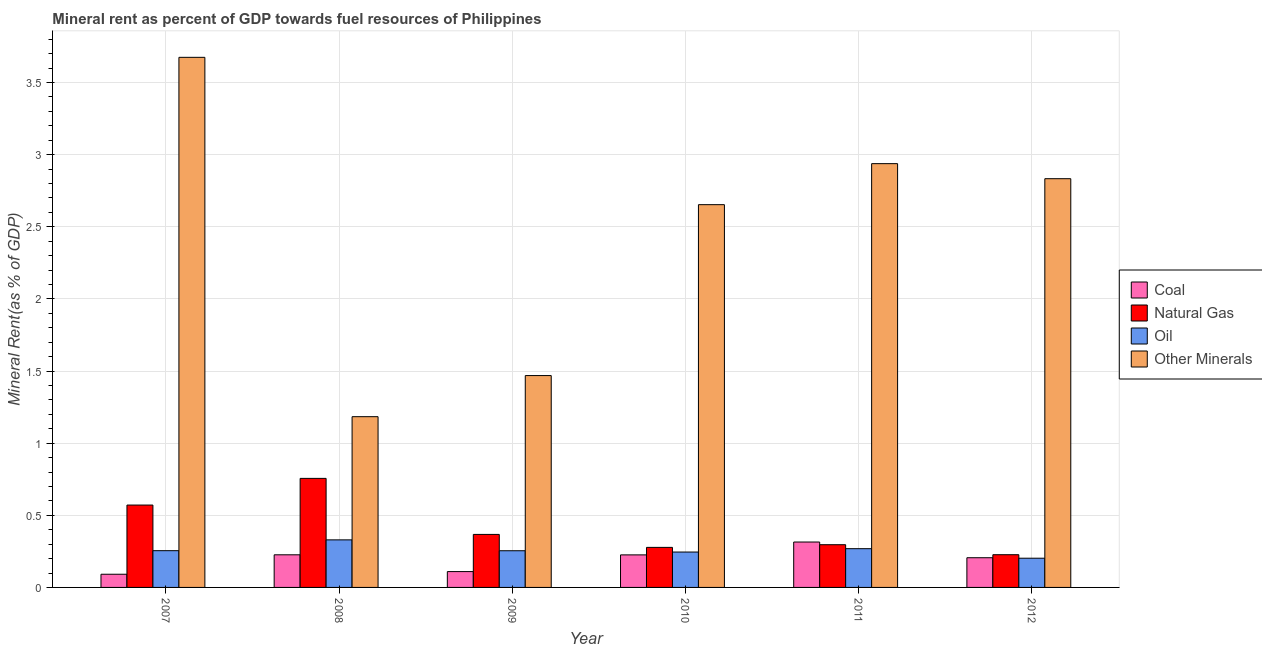How many different coloured bars are there?
Offer a terse response. 4. How many groups of bars are there?
Provide a succinct answer. 6. Are the number of bars per tick equal to the number of legend labels?
Your answer should be very brief. Yes. Are the number of bars on each tick of the X-axis equal?
Your answer should be very brief. Yes. How many bars are there on the 6th tick from the left?
Offer a terse response. 4. How many bars are there on the 2nd tick from the right?
Your answer should be very brief. 4. What is the label of the 5th group of bars from the left?
Offer a very short reply. 2011. What is the  rent of other minerals in 2009?
Provide a succinct answer. 1.47. Across all years, what is the maximum coal rent?
Your response must be concise. 0.31. Across all years, what is the minimum oil rent?
Provide a short and direct response. 0.2. What is the total coal rent in the graph?
Offer a very short reply. 1.17. What is the difference between the coal rent in 2009 and that in 2011?
Keep it short and to the point. -0.2. What is the difference between the coal rent in 2008 and the  rent of other minerals in 2010?
Ensure brevity in your answer.  0. What is the average  rent of other minerals per year?
Provide a short and direct response. 2.46. What is the ratio of the  rent of other minerals in 2008 to that in 2012?
Provide a short and direct response. 0.42. Is the  rent of other minerals in 2007 less than that in 2009?
Offer a very short reply. No. What is the difference between the highest and the second highest coal rent?
Offer a very short reply. 0.09. What is the difference between the highest and the lowest oil rent?
Make the answer very short. 0.13. In how many years, is the natural gas rent greater than the average natural gas rent taken over all years?
Provide a succinct answer. 2. What does the 2nd bar from the left in 2010 represents?
Make the answer very short. Natural Gas. What does the 3rd bar from the right in 2010 represents?
Your answer should be very brief. Natural Gas. Is it the case that in every year, the sum of the coal rent and natural gas rent is greater than the oil rent?
Your response must be concise. Yes. How many years are there in the graph?
Your answer should be compact. 6. Are the values on the major ticks of Y-axis written in scientific E-notation?
Ensure brevity in your answer.  No. Does the graph contain any zero values?
Offer a very short reply. No. Does the graph contain grids?
Offer a very short reply. Yes. How many legend labels are there?
Ensure brevity in your answer.  4. How are the legend labels stacked?
Your answer should be very brief. Vertical. What is the title of the graph?
Offer a terse response. Mineral rent as percent of GDP towards fuel resources of Philippines. What is the label or title of the X-axis?
Ensure brevity in your answer.  Year. What is the label or title of the Y-axis?
Your response must be concise. Mineral Rent(as % of GDP). What is the Mineral Rent(as % of GDP) in Coal in 2007?
Give a very brief answer. 0.09. What is the Mineral Rent(as % of GDP) in Natural Gas in 2007?
Your answer should be very brief. 0.57. What is the Mineral Rent(as % of GDP) in Oil in 2007?
Make the answer very short. 0.25. What is the Mineral Rent(as % of GDP) of Other Minerals in 2007?
Your answer should be compact. 3.67. What is the Mineral Rent(as % of GDP) in Coal in 2008?
Provide a short and direct response. 0.23. What is the Mineral Rent(as % of GDP) of Natural Gas in 2008?
Give a very brief answer. 0.76. What is the Mineral Rent(as % of GDP) of Oil in 2008?
Provide a succinct answer. 0.33. What is the Mineral Rent(as % of GDP) of Other Minerals in 2008?
Make the answer very short. 1.18. What is the Mineral Rent(as % of GDP) of Coal in 2009?
Ensure brevity in your answer.  0.11. What is the Mineral Rent(as % of GDP) of Natural Gas in 2009?
Ensure brevity in your answer.  0.37. What is the Mineral Rent(as % of GDP) in Oil in 2009?
Your response must be concise. 0.25. What is the Mineral Rent(as % of GDP) of Other Minerals in 2009?
Offer a very short reply. 1.47. What is the Mineral Rent(as % of GDP) in Coal in 2010?
Provide a short and direct response. 0.23. What is the Mineral Rent(as % of GDP) of Natural Gas in 2010?
Provide a succinct answer. 0.28. What is the Mineral Rent(as % of GDP) in Oil in 2010?
Make the answer very short. 0.25. What is the Mineral Rent(as % of GDP) of Other Minerals in 2010?
Your answer should be very brief. 2.65. What is the Mineral Rent(as % of GDP) of Coal in 2011?
Your response must be concise. 0.31. What is the Mineral Rent(as % of GDP) of Natural Gas in 2011?
Your answer should be very brief. 0.3. What is the Mineral Rent(as % of GDP) of Oil in 2011?
Your answer should be very brief. 0.27. What is the Mineral Rent(as % of GDP) of Other Minerals in 2011?
Ensure brevity in your answer.  2.94. What is the Mineral Rent(as % of GDP) of Coal in 2012?
Your answer should be very brief. 0.21. What is the Mineral Rent(as % of GDP) in Natural Gas in 2012?
Offer a terse response. 0.23. What is the Mineral Rent(as % of GDP) in Oil in 2012?
Make the answer very short. 0.2. What is the Mineral Rent(as % of GDP) of Other Minerals in 2012?
Your answer should be compact. 2.83. Across all years, what is the maximum Mineral Rent(as % of GDP) in Coal?
Provide a short and direct response. 0.31. Across all years, what is the maximum Mineral Rent(as % of GDP) of Natural Gas?
Make the answer very short. 0.76. Across all years, what is the maximum Mineral Rent(as % of GDP) in Oil?
Your answer should be very brief. 0.33. Across all years, what is the maximum Mineral Rent(as % of GDP) of Other Minerals?
Give a very brief answer. 3.67. Across all years, what is the minimum Mineral Rent(as % of GDP) in Coal?
Ensure brevity in your answer.  0.09. Across all years, what is the minimum Mineral Rent(as % of GDP) in Natural Gas?
Your answer should be compact. 0.23. Across all years, what is the minimum Mineral Rent(as % of GDP) in Oil?
Offer a terse response. 0.2. Across all years, what is the minimum Mineral Rent(as % of GDP) in Other Minerals?
Your response must be concise. 1.18. What is the total Mineral Rent(as % of GDP) in Coal in the graph?
Your response must be concise. 1.17. What is the total Mineral Rent(as % of GDP) of Natural Gas in the graph?
Ensure brevity in your answer.  2.5. What is the total Mineral Rent(as % of GDP) of Oil in the graph?
Keep it short and to the point. 1.56. What is the total Mineral Rent(as % of GDP) in Other Minerals in the graph?
Offer a terse response. 14.75. What is the difference between the Mineral Rent(as % of GDP) in Coal in 2007 and that in 2008?
Offer a very short reply. -0.13. What is the difference between the Mineral Rent(as % of GDP) in Natural Gas in 2007 and that in 2008?
Your response must be concise. -0.18. What is the difference between the Mineral Rent(as % of GDP) of Oil in 2007 and that in 2008?
Provide a short and direct response. -0.07. What is the difference between the Mineral Rent(as % of GDP) of Other Minerals in 2007 and that in 2008?
Give a very brief answer. 2.49. What is the difference between the Mineral Rent(as % of GDP) in Coal in 2007 and that in 2009?
Offer a very short reply. -0.02. What is the difference between the Mineral Rent(as % of GDP) in Natural Gas in 2007 and that in 2009?
Your answer should be very brief. 0.2. What is the difference between the Mineral Rent(as % of GDP) in Other Minerals in 2007 and that in 2009?
Offer a very short reply. 2.21. What is the difference between the Mineral Rent(as % of GDP) in Coal in 2007 and that in 2010?
Your answer should be very brief. -0.13. What is the difference between the Mineral Rent(as % of GDP) in Natural Gas in 2007 and that in 2010?
Offer a terse response. 0.29. What is the difference between the Mineral Rent(as % of GDP) of Oil in 2007 and that in 2010?
Offer a terse response. 0.01. What is the difference between the Mineral Rent(as % of GDP) of Other Minerals in 2007 and that in 2010?
Offer a terse response. 1.02. What is the difference between the Mineral Rent(as % of GDP) in Coal in 2007 and that in 2011?
Give a very brief answer. -0.22. What is the difference between the Mineral Rent(as % of GDP) of Natural Gas in 2007 and that in 2011?
Provide a short and direct response. 0.27. What is the difference between the Mineral Rent(as % of GDP) in Oil in 2007 and that in 2011?
Offer a very short reply. -0.01. What is the difference between the Mineral Rent(as % of GDP) of Other Minerals in 2007 and that in 2011?
Your answer should be very brief. 0.74. What is the difference between the Mineral Rent(as % of GDP) in Coal in 2007 and that in 2012?
Make the answer very short. -0.11. What is the difference between the Mineral Rent(as % of GDP) of Natural Gas in 2007 and that in 2012?
Make the answer very short. 0.34. What is the difference between the Mineral Rent(as % of GDP) of Oil in 2007 and that in 2012?
Keep it short and to the point. 0.05. What is the difference between the Mineral Rent(as % of GDP) in Other Minerals in 2007 and that in 2012?
Provide a short and direct response. 0.84. What is the difference between the Mineral Rent(as % of GDP) in Coal in 2008 and that in 2009?
Your answer should be very brief. 0.12. What is the difference between the Mineral Rent(as % of GDP) in Natural Gas in 2008 and that in 2009?
Your response must be concise. 0.39. What is the difference between the Mineral Rent(as % of GDP) of Oil in 2008 and that in 2009?
Provide a succinct answer. 0.08. What is the difference between the Mineral Rent(as % of GDP) of Other Minerals in 2008 and that in 2009?
Provide a succinct answer. -0.28. What is the difference between the Mineral Rent(as % of GDP) in Coal in 2008 and that in 2010?
Your response must be concise. 0. What is the difference between the Mineral Rent(as % of GDP) in Natural Gas in 2008 and that in 2010?
Provide a succinct answer. 0.48. What is the difference between the Mineral Rent(as % of GDP) in Oil in 2008 and that in 2010?
Your answer should be compact. 0.08. What is the difference between the Mineral Rent(as % of GDP) of Other Minerals in 2008 and that in 2010?
Keep it short and to the point. -1.47. What is the difference between the Mineral Rent(as % of GDP) in Coal in 2008 and that in 2011?
Provide a short and direct response. -0.09. What is the difference between the Mineral Rent(as % of GDP) of Natural Gas in 2008 and that in 2011?
Offer a very short reply. 0.46. What is the difference between the Mineral Rent(as % of GDP) in Oil in 2008 and that in 2011?
Your answer should be very brief. 0.06. What is the difference between the Mineral Rent(as % of GDP) in Other Minerals in 2008 and that in 2011?
Keep it short and to the point. -1.75. What is the difference between the Mineral Rent(as % of GDP) in Coal in 2008 and that in 2012?
Give a very brief answer. 0.02. What is the difference between the Mineral Rent(as % of GDP) in Natural Gas in 2008 and that in 2012?
Keep it short and to the point. 0.53. What is the difference between the Mineral Rent(as % of GDP) of Oil in 2008 and that in 2012?
Offer a terse response. 0.13. What is the difference between the Mineral Rent(as % of GDP) in Other Minerals in 2008 and that in 2012?
Make the answer very short. -1.65. What is the difference between the Mineral Rent(as % of GDP) of Coal in 2009 and that in 2010?
Offer a very short reply. -0.12. What is the difference between the Mineral Rent(as % of GDP) in Natural Gas in 2009 and that in 2010?
Provide a short and direct response. 0.09. What is the difference between the Mineral Rent(as % of GDP) of Oil in 2009 and that in 2010?
Ensure brevity in your answer.  0.01. What is the difference between the Mineral Rent(as % of GDP) in Other Minerals in 2009 and that in 2010?
Make the answer very short. -1.18. What is the difference between the Mineral Rent(as % of GDP) of Coal in 2009 and that in 2011?
Your response must be concise. -0.2. What is the difference between the Mineral Rent(as % of GDP) in Natural Gas in 2009 and that in 2011?
Ensure brevity in your answer.  0.07. What is the difference between the Mineral Rent(as % of GDP) in Oil in 2009 and that in 2011?
Your response must be concise. -0.01. What is the difference between the Mineral Rent(as % of GDP) of Other Minerals in 2009 and that in 2011?
Offer a terse response. -1.47. What is the difference between the Mineral Rent(as % of GDP) in Coal in 2009 and that in 2012?
Keep it short and to the point. -0.1. What is the difference between the Mineral Rent(as % of GDP) of Natural Gas in 2009 and that in 2012?
Provide a short and direct response. 0.14. What is the difference between the Mineral Rent(as % of GDP) of Oil in 2009 and that in 2012?
Your response must be concise. 0.05. What is the difference between the Mineral Rent(as % of GDP) in Other Minerals in 2009 and that in 2012?
Provide a short and direct response. -1.36. What is the difference between the Mineral Rent(as % of GDP) of Coal in 2010 and that in 2011?
Provide a short and direct response. -0.09. What is the difference between the Mineral Rent(as % of GDP) in Natural Gas in 2010 and that in 2011?
Offer a very short reply. -0.02. What is the difference between the Mineral Rent(as % of GDP) in Oil in 2010 and that in 2011?
Provide a short and direct response. -0.02. What is the difference between the Mineral Rent(as % of GDP) in Other Minerals in 2010 and that in 2011?
Your response must be concise. -0.28. What is the difference between the Mineral Rent(as % of GDP) in Coal in 2010 and that in 2012?
Offer a very short reply. 0.02. What is the difference between the Mineral Rent(as % of GDP) of Natural Gas in 2010 and that in 2012?
Offer a terse response. 0.05. What is the difference between the Mineral Rent(as % of GDP) in Oil in 2010 and that in 2012?
Provide a short and direct response. 0.04. What is the difference between the Mineral Rent(as % of GDP) of Other Minerals in 2010 and that in 2012?
Provide a short and direct response. -0.18. What is the difference between the Mineral Rent(as % of GDP) in Coal in 2011 and that in 2012?
Make the answer very short. 0.11. What is the difference between the Mineral Rent(as % of GDP) of Natural Gas in 2011 and that in 2012?
Ensure brevity in your answer.  0.07. What is the difference between the Mineral Rent(as % of GDP) in Oil in 2011 and that in 2012?
Ensure brevity in your answer.  0.07. What is the difference between the Mineral Rent(as % of GDP) of Other Minerals in 2011 and that in 2012?
Offer a very short reply. 0.1. What is the difference between the Mineral Rent(as % of GDP) in Coal in 2007 and the Mineral Rent(as % of GDP) in Natural Gas in 2008?
Keep it short and to the point. -0.66. What is the difference between the Mineral Rent(as % of GDP) of Coal in 2007 and the Mineral Rent(as % of GDP) of Oil in 2008?
Make the answer very short. -0.24. What is the difference between the Mineral Rent(as % of GDP) of Coal in 2007 and the Mineral Rent(as % of GDP) of Other Minerals in 2008?
Make the answer very short. -1.09. What is the difference between the Mineral Rent(as % of GDP) of Natural Gas in 2007 and the Mineral Rent(as % of GDP) of Oil in 2008?
Keep it short and to the point. 0.24. What is the difference between the Mineral Rent(as % of GDP) in Natural Gas in 2007 and the Mineral Rent(as % of GDP) in Other Minerals in 2008?
Offer a very short reply. -0.61. What is the difference between the Mineral Rent(as % of GDP) of Oil in 2007 and the Mineral Rent(as % of GDP) of Other Minerals in 2008?
Give a very brief answer. -0.93. What is the difference between the Mineral Rent(as % of GDP) of Coal in 2007 and the Mineral Rent(as % of GDP) of Natural Gas in 2009?
Give a very brief answer. -0.28. What is the difference between the Mineral Rent(as % of GDP) in Coal in 2007 and the Mineral Rent(as % of GDP) in Oil in 2009?
Provide a succinct answer. -0.16. What is the difference between the Mineral Rent(as % of GDP) of Coal in 2007 and the Mineral Rent(as % of GDP) of Other Minerals in 2009?
Your response must be concise. -1.38. What is the difference between the Mineral Rent(as % of GDP) in Natural Gas in 2007 and the Mineral Rent(as % of GDP) in Oil in 2009?
Your answer should be very brief. 0.32. What is the difference between the Mineral Rent(as % of GDP) in Natural Gas in 2007 and the Mineral Rent(as % of GDP) in Other Minerals in 2009?
Your answer should be very brief. -0.9. What is the difference between the Mineral Rent(as % of GDP) of Oil in 2007 and the Mineral Rent(as % of GDP) of Other Minerals in 2009?
Make the answer very short. -1.21. What is the difference between the Mineral Rent(as % of GDP) in Coal in 2007 and the Mineral Rent(as % of GDP) in Natural Gas in 2010?
Make the answer very short. -0.19. What is the difference between the Mineral Rent(as % of GDP) of Coal in 2007 and the Mineral Rent(as % of GDP) of Oil in 2010?
Keep it short and to the point. -0.15. What is the difference between the Mineral Rent(as % of GDP) in Coal in 2007 and the Mineral Rent(as % of GDP) in Other Minerals in 2010?
Your response must be concise. -2.56. What is the difference between the Mineral Rent(as % of GDP) in Natural Gas in 2007 and the Mineral Rent(as % of GDP) in Oil in 2010?
Offer a very short reply. 0.33. What is the difference between the Mineral Rent(as % of GDP) of Natural Gas in 2007 and the Mineral Rent(as % of GDP) of Other Minerals in 2010?
Give a very brief answer. -2.08. What is the difference between the Mineral Rent(as % of GDP) in Oil in 2007 and the Mineral Rent(as % of GDP) in Other Minerals in 2010?
Your answer should be compact. -2.4. What is the difference between the Mineral Rent(as % of GDP) of Coal in 2007 and the Mineral Rent(as % of GDP) of Natural Gas in 2011?
Offer a terse response. -0.2. What is the difference between the Mineral Rent(as % of GDP) of Coal in 2007 and the Mineral Rent(as % of GDP) of Oil in 2011?
Your answer should be very brief. -0.18. What is the difference between the Mineral Rent(as % of GDP) in Coal in 2007 and the Mineral Rent(as % of GDP) in Other Minerals in 2011?
Offer a terse response. -2.85. What is the difference between the Mineral Rent(as % of GDP) of Natural Gas in 2007 and the Mineral Rent(as % of GDP) of Oil in 2011?
Your response must be concise. 0.3. What is the difference between the Mineral Rent(as % of GDP) of Natural Gas in 2007 and the Mineral Rent(as % of GDP) of Other Minerals in 2011?
Your answer should be very brief. -2.37. What is the difference between the Mineral Rent(as % of GDP) of Oil in 2007 and the Mineral Rent(as % of GDP) of Other Minerals in 2011?
Keep it short and to the point. -2.68. What is the difference between the Mineral Rent(as % of GDP) in Coal in 2007 and the Mineral Rent(as % of GDP) in Natural Gas in 2012?
Your answer should be very brief. -0.14. What is the difference between the Mineral Rent(as % of GDP) in Coal in 2007 and the Mineral Rent(as % of GDP) in Oil in 2012?
Keep it short and to the point. -0.11. What is the difference between the Mineral Rent(as % of GDP) in Coal in 2007 and the Mineral Rent(as % of GDP) in Other Minerals in 2012?
Provide a short and direct response. -2.74. What is the difference between the Mineral Rent(as % of GDP) of Natural Gas in 2007 and the Mineral Rent(as % of GDP) of Oil in 2012?
Provide a short and direct response. 0.37. What is the difference between the Mineral Rent(as % of GDP) of Natural Gas in 2007 and the Mineral Rent(as % of GDP) of Other Minerals in 2012?
Your answer should be compact. -2.26. What is the difference between the Mineral Rent(as % of GDP) in Oil in 2007 and the Mineral Rent(as % of GDP) in Other Minerals in 2012?
Your answer should be very brief. -2.58. What is the difference between the Mineral Rent(as % of GDP) of Coal in 2008 and the Mineral Rent(as % of GDP) of Natural Gas in 2009?
Keep it short and to the point. -0.14. What is the difference between the Mineral Rent(as % of GDP) of Coal in 2008 and the Mineral Rent(as % of GDP) of Oil in 2009?
Give a very brief answer. -0.03. What is the difference between the Mineral Rent(as % of GDP) of Coal in 2008 and the Mineral Rent(as % of GDP) of Other Minerals in 2009?
Provide a short and direct response. -1.24. What is the difference between the Mineral Rent(as % of GDP) in Natural Gas in 2008 and the Mineral Rent(as % of GDP) in Oil in 2009?
Give a very brief answer. 0.5. What is the difference between the Mineral Rent(as % of GDP) of Natural Gas in 2008 and the Mineral Rent(as % of GDP) of Other Minerals in 2009?
Your answer should be very brief. -0.71. What is the difference between the Mineral Rent(as % of GDP) in Oil in 2008 and the Mineral Rent(as % of GDP) in Other Minerals in 2009?
Your answer should be compact. -1.14. What is the difference between the Mineral Rent(as % of GDP) in Coal in 2008 and the Mineral Rent(as % of GDP) in Natural Gas in 2010?
Ensure brevity in your answer.  -0.05. What is the difference between the Mineral Rent(as % of GDP) in Coal in 2008 and the Mineral Rent(as % of GDP) in Oil in 2010?
Your answer should be very brief. -0.02. What is the difference between the Mineral Rent(as % of GDP) of Coal in 2008 and the Mineral Rent(as % of GDP) of Other Minerals in 2010?
Give a very brief answer. -2.43. What is the difference between the Mineral Rent(as % of GDP) of Natural Gas in 2008 and the Mineral Rent(as % of GDP) of Oil in 2010?
Give a very brief answer. 0.51. What is the difference between the Mineral Rent(as % of GDP) in Natural Gas in 2008 and the Mineral Rent(as % of GDP) in Other Minerals in 2010?
Provide a short and direct response. -1.9. What is the difference between the Mineral Rent(as % of GDP) in Oil in 2008 and the Mineral Rent(as % of GDP) in Other Minerals in 2010?
Your answer should be very brief. -2.32. What is the difference between the Mineral Rent(as % of GDP) in Coal in 2008 and the Mineral Rent(as % of GDP) in Natural Gas in 2011?
Offer a terse response. -0.07. What is the difference between the Mineral Rent(as % of GDP) in Coal in 2008 and the Mineral Rent(as % of GDP) in Oil in 2011?
Your answer should be compact. -0.04. What is the difference between the Mineral Rent(as % of GDP) in Coal in 2008 and the Mineral Rent(as % of GDP) in Other Minerals in 2011?
Offer a terse response. -2.71. What is the difference between the Mineral Rent(as % of GDP) of Natural Gas in 2008 and the Mineral Rent(as % of GDP) of Oil in 2011?
Provide a short and direct response. 0.49. What is the difference between the Mineral Rent(as % of GDP) in Natural Gas in 2008 and the Mineral Rent(as % of GDP) in Other Minerals in 2011?
Provide a short and direct response. -2.18. What is the difference between the Mineral Rent(as % of GDP) of Oil in 2008 and the Mineral Rent(as % of GDP) of Other Minerals in 2011?
Provide a succinct answer. -2.61. What is the difference between the Mineral Rent(as % of GDP) of Coal in 2008 and the Mineral Rent(as % of GDP) of Natural Gas in 2012?
Keep it short and to the point. -0. What is the difference between the Mineral Rent(as % of GDP) in Coal in 2008 and the Mineral Rent(as % of GDP) in Oil in 2012?
Your answer should be very brief. 0.02. What is the difference between the Mineral Rent(as % of GDP) in Coal in 2008 and the Mineral Rent(as % of GDP) in Other Minerals in 2012?
Keep it short and to the point. -2.61. What is the difference between the Mineral Rent(as % of GDP) of Natural Gas in 2008 and the Mineral Rent(as % of GDP) of Oil in 2012?
Offer a terse response. 0.55. What is the difference between the Mineral Rent(as % of GDP) of Natural Gas in 2008 and the Mineral Rent(as % of GDP) of Other Minerals in 2012?
Ensure brevity in your answer.  -2.08. What is the difference between the Mineral Rent(as % of GDP) in Oil in 2008 and the Mineral Rent(as % of GDP) in Other Minerals in 2012?
Keep it short and to the point. -2.5. What is the difference between the Mineral Rent(as % of GDP) in Coal in 2009 and the Mineral Rent(as % of GDP) in Natural Gas in 2010?
Keep it short and to the point. -0.17. What is the difference between the Mineral Rent(as % of GDP) in Coal in 2009 and the Mineral Rent(as % of GDP) in Oil in 2010?
Provide a succinct answer. -0.14. What is the difference between the Mineral Rent(as % of GDP) in Coal in 2009 and the Mineral Rent(as % of GDP) in Other Minerals in 2010?
Provide a succinct answer. -2.54. What is the difference between the Mineral Rent(as % of GDP) in Natural Gas in 2009 and the Mineral Rent(as % of GDP) in Oil in 2010?
Your answer should be compact. 0.12. What is the difference between the Mineral Rent(as % of GDP) in Natural Gas in 2009 and the Mineral Rent(as % of GDP) in Other Minerals in 2010?
Keep it short and to the point. -2.29. What is the difference between the Mineral Rent(as % of GDP) of Oil in 2009 and the Mineral Rent(as % of GDP) of Other Minerals in 2010?
Offer a terse response. -2.4. What is the difference between the Mineral Rent(as % of GDP) in Coal in 2009 and the Mineral Rent(as % of GDP) in Natural Gas in 2011?
Give a very brief answer. -0.19. What is the difference between the Mineral Rent(as % of GDP) in Coal in 2009 and the Mineral Rent(as % of GDP) in Oil in 2011?
Ensure brevity in your answer.  -0.16. What is the difference between the Mineral Rent(as % of GDP) of Coal in 2009 and the Mineral Rent(as % of GDP) of Other Minerals in 2011?
Provide a short and direct response. -2.83. What is the difference between the Mineral Rent(as % of GDP) of Natural Gas in 2009 and the Mineral Rent(as % of GDP) of Oil in 2011?
Provide a short and direct response. 0.1. What is the difference between the Mineral Rent(as % of GDP) of Natural Gas in 2009 and the Mineral Rent(as % of GDP) of Other Minerals in 2011?
Offer a terse response. -2.57. What is the difference between the Mineral Rent(as % of GDP) in Oil in 2009 and the Mineral Rent(as % of GDP) in Other Minerals in 2011?
Provide a short and direct response. -2.68. What is the difference between the Mineral Rent(as % of GDP) in Coal in 2009 and the Mineral Rent(as % of GDP) in Natural Gas in 2012?
Provide a short and direct response. -0.12. What is the difference between the Mineral Rent(as % of GDP) of Coal in 2009 and the Mineral Rent(as % of GDP) of Oil in 2012?
Keep it short and to the point. -0.09. What is the difference between the Mineral Rent(as % of GDP) in Coal in 2009 and the Mineral Rent(as % of GDP) in Other Minerals in 2012?
Your answer should be compact. -2.72. What is the difference between the Mineral Rent(as % of GDP) in Natural Gas in 2009 and the Mineral Rent(as % of GDP) in Oil in 2012?
Offer a very short reply. 0.17. What is the difference between the Mineral Rent(as % of GDP) of Natural Gas in 2009 and the Mineral Rent(as % of GDP) of Other Minerals in 2012?
Offer a very short reply. -2.47. What is the difference between the Mineral Rent(as % of GDP) of Oil in 2009 and the Mineral Rent(as % of GDP) of Other Minerals in 2012?
Offer a terse response. -2.58. What is the difference between the Mineral Rent(as % of GDP) of Coal in 2010 and the Mineral Rent(as % of GDP) of Natural Gas in 2011?
Your answer should be compact. -0.07. What is the difference between the Mineral Rent(as % of GDP) in Coal in 2010 and the Mineral Rent(as % of GDP) in Oil in 2011?
Your response must be concise. -0.04. What is the difference between the Mineral Rent(as % of GDP) of Coal in 2010 and the Mineral Rent(as % of GDP) of Other Minerals in 2011?
Give a very brief answer. -2.71. What is the difference between the Mineral Rent(as % of GDP) of Natural Gas in 2010 and the Mineral Rent(as % of GDP) of Oil in 2011?
Your answer should be very brief. 0.01. What is the difference between the Mineral Rent(as % of GDP) of Natural Gas in 2010 and the Mineral Rent(as % of GDP) of Other Minerals in 2011?
Offer a very short reply. -2.66. What is the difference between the Mineral Rent(as % of GDP) in Oil in 2010 and the Mineral Rent(as % of GDP) in Other Minerals in 2011?
Your answer should be very brief. -2.69. What is the difference between the Mineral Rent(as % of GDP) of Coal in 2010 and the Mineral Rent(as % of GDP) of Natural Gas in 2012?
Give a very brief answer. -0. What is the difference between the Mineral Rent(as % of GDP) of Coal in 2010 and the Mineral Rent(as % of GDP) of Oil in 2012?
Your answer should be compact. 0.02. What is the difference between the Mineral Rent(as % of GDP) of Coal in 2010 and the Mineral Rent(as % of GDP) of Other Minerals in 2012?
Make the answer very short. -2.61. What is the difference between the Mineral Rent(as % of GDP) in Natural Gas in 2010 and the Mineral Rent(as % of GDP) in Oil in 2012?
Offer a terse response. 0.07. What is the difference between the Mineral Rent(as % of GDP) of Natural Gas in 2010 and the Mineral Rent(as % of GDP) of Other Minerals in 2012?
Your response must be concise. -2.56. What is the difference between the Mineral Rent(as % of GDP) in Oil in 2010 and the Mineral Rent(as % of GDP) in Other Minerals in 2012?
Offer a terse response. -2.59. What is the difference between the Mineral Rent(as % of GDP) of Coal in 2011 and the Mineral Rent(as % of GDP) of Natural Gas in 2012?
Your response must be concise. 0.09. What is the difference between the Mineral Rent(as % of GDP) of Coal in 2011 and the Mineral Rent(as % of GDP) of Oil in 2012?
Your response must be concise. 0.11. What is the difference between the Mineral Rent(as % of GDP) in Coal in 2011 and the Mineral Rent(as % of GDP) in Other Minerals in 2012?
Offer a terse response. -2.52. What is the difference between the Mineral Rent(as % of GDP) in Natural Gas in 2011 and the Mineral Rent(as % of GDP) in Oil in 2012?
Provide a succinct answer. 0.09. What is the difference between the Mineral Rent(as % of GDP) in Natural Gas in 2011 and the Mineral Rent(as % of GDP) in Other Minerals in 2012?
Your answer should be compact. -2.54. What is the difference between the Mineral Rent(as % of GDP) in Oil in 2011 and the Mineral Rent(as % of GDP) in Other Minerals in 2012?
Provide a short and direct response. -2.56. What is the average Mineral Rent(as % of GDP) of Coal per year?
Your answer should be very brief. 0.2. What is the average Mineral Rent(as % of GDP) in Natural Gas per year?
Keep it short and to the point. 0.42. What is the average Mineral Rent(as % of GDP) in Oil per year?
Offer a very short reply. 0.26. What is the average Mineral Rent(as % of GDP) in Other Minerals per year?
Keep it short and to the point. 2.46. In the year 2007, what is the difference between the Mineral Rent(as % of GDP) of Coal and Mineral Rent(as % of GDP) of Natural Gas?
Provide a short and direct response. -0.48. In the year 2007, what is the difference between the Mineral Rent(as % of GDP) of Coal and Mineral Rent(as % of GDP) of Oil?
Offer a very short reply. -0.16. In the year 2007, what is the difference between the Mineral Rent(as % of GDP) of Coal and Mineral Rent(as % of GDP) of Other Minerals?
Offer a very short reply. -3.58. In the year 2007, what is the difference between the Mineral Rent(as % of GDP) of Natural Gas and Mineral Rent(as % of GDP) of Oil?
Ensure brevity in your answer.  0.32. In the year 2007, what is the difference between the Mineral Rent(as % of GDP) in Natural Gas and Mineral Rent(as % of GDP) in Other Minerals?
Make the answer very short. -3.1. In the year 2007, what is the difference between the Mineral Rent(as % of GDP) in Oil and Mineral Rent(as % of GDP) in Other Minerals?
Offer a terse response. -3.42. In the year 2008, what is the difference between the Mineral Rent(as % of GDP) of Coal and Mineral Rent(as % of GDP) of Natural Gas?
Provide a succinct answer. -0.53. In the year 2008, what is the difference between the Mineral Rent(as % of GDP) in Coal and Mineral Rent(as % of GDP) in Oil?
Provide a short and direct response. -0.1. In the year 2008, what is the difference between the Mineral Rent(as % of GDP) of Coal and Mineral Rent(as % of GDP) of Other Minerals?
Your answer should be compact. -0.96. In the year 2008, what is the difference between the Mineral Rent(as % of GDP) of Natural Gas and Mineral Rent(as % of GDP) of Oil?
Your answer should be very brief. 0.43. In the year 2008, what is the difference between the Mineral Rent(as % of GDP) of Natural Gas and Mineral Rent(as % of GDP) of Other Minerals?
Give a very brief answer. -0.43. In the year 2008, what is the difference between the Mineral Rent(as % of GDP) of Oil and Mineral Rent(as % of GDP) of Other Minerals?
Make the answer very short. -0.85. In the year 2009, what is the difference between the Mineral Rent(as % of GDP) of Coal and Mineral Rent(as % of GDP) of Natural Gas?
Provide a succinct answer. -0.26. In the year 2009, what is the difference between the Mineral Rent(as % of GDP) of Coal and Mineral Rent(as % of GDP) of Oil?
Make the answer very short. -0.14. In the year 2009, what is the difference between the Mineral Rent(as % of GDP) in Coal and Mineral Rent(as % of GDP) in Other Minerals?
Your answer should be very brief. -1.36. In the year 2009, what is the difference between the Mineral Rent(as % of GDP) in Natural Gas and Mineral Rent(as % of GDP) in Oil?
Your answer should be very brief. 0.11. In the year 2009, what is the difference between the Mineral Rent(as % of GDP) of Natural Gas and Mineral Rent(as % of GDP) of Other Minerals?
Ensure brevity in your answer.  -1.1. In the year 2009, what is the difference between the Mineral Rent(as % of GDP) of Oil and Mineral Rent(as % of GDP) of Other Minerals?
Your answer should be compact. -1.21. In the year 2010, what is the difference between the Mineral Rent(as % of GDP) in Coal and Mineral Rent(as % of GDP) in Natural Gas?
Give a very brief answer. -0.05. In the year 2010, what is the difference between the Mineral Rent(as % of GDP) in Coal and Mineral Rent(as % of GDP) in Oil?
Offer a terse response. -0.02. In the year 2010, what is the difference between the Mineral Rent(as % of GDP) of Coal and Mineral Rent(as % of GDP) of Other Minerals?
Offer a terse response. -2.43. In the year 2010, what is the difference between the Mineral Rent(as % of GDP) in Natural Gas and Mineral Rent(as % of GDP) in Oil?
Your answer should be very brief. 0.03. In the year 2010, what is the difference between the Mineral Rent(as % of GDP) in Natural Gas and Mineral Rent(as % of GDP) in Other Minerals?
Provide a short and direct response. -2.38. In the year 2010, what is the difference between the Mineral Rent(as % of GDP) in Oil and Mineral Rent(as % of GDP) in Other Minerals?
Your answer should be compact. -2.41. In the year 2011, what is the difference between the Mineral Rent(as % of GDP) in Coal and Mineral Rent(as % of GDP) in Natural Gas?
Offer a terse response. 0.02. In the year 2011, what is the difference between the Mineral Rent(as % of GDP) in Coal and Mineral Rent(as % of GDP) in Oil?
Make the answer very short. 0.05. In the year 2011, what is the difference between the Mineral Rent(as % of GDP) in Coal and Mineral Rent(as % of GDP) in Other Minerals?
Offer a terse response. -2.62. In the year 2011, what is the difference between the Mineral Rent(as % of GDP) in Natural Gas and Mineral Rent(as % of GDP) in Oil?
Offer a very short reply. 0.03. In the year 2011, what is the difference between the Mineral Rent(as % of GDP) in Natural Gas and Mineral Rent(as % of GDP) in Other Minerals?
Provide a succinct answer. -2.64. In the year 2011, what is the difference between the Mineral Rent(as % of GDP) in Oil and Mineral Rent(as % of GDP) in Other Minerals?
Offer a terse response. -2.67. In the year 2012, what is the difference between the Mineral Rent(as % of GDP) of Coal and Mineral Rent(as % of GDP) of Natural Gas?
Offer a very short reply. -0.02. In the year 2012, what is the difference between the Mineral Rent(as % of GDP) of Coal and Mineral Rent(as % of GDP) of Oil?
Make the answer very short. 0. In the year 2012, what is the difference between the Mineral Rent(as % of GDP) of Coal and Mineral Rent(as % of GDP) of Other Minerals?
Provide a short and direct response. -2.63. In the year 2012, what is the difference between the Mineral Rent(as % of GDP) of Natural Gas and Mineral Rent(as % of GDP) of Oil?
Offer a very short reply. 0.02. In the year 2012, what is the difference between the Mineral Rent(as % of GDP) of Natural Gas and Mineral Rent(as % of GDP) of Other Minerals?
Provide a short and direct response. -2.61. In the year 2012, what is the difference between the Mineral Rent(as % of GDP) of Oil and Mineral Rent(as % of GDP) of Other Minerals?
Your answer should be very brief. -2.63. What is the ratio of the Mineral Rent(as % of GDP) in Coal in 2007 to that in 2008?
Offer a terse response. 0.4. What is the ratio of the Mineral Rent(as % of GDP) of Natural Gas in 2007 to that in 2008?
Give a very brief answer. 0.76. What is the ratio of the Mineral Rent(as % of GDP) in Oil in 2007 to that in 2008?
Make the answer very short. 0.77. What is the ratio of the Mineral Rent(as % of GDP) of Other Minerals in 2007 to that in 2008?
Provide a short and direct response. 3.1. What is the ratio of the Mineral Rent(as % of GDP) of Coal in 2007 to that in 2009?
Give a very brief answer. 0.83. What is the ratio of the Mineral Rent(as % of GDP) in Natural Gas in 2007 to that in 2009?
Offer a terse response. 1.55. What is the ratio of the Mineral Rent(as % of GDP) in Other Minerals in 2007 to that in 2009?
Provide a short and direct response. 2.5. What is the ratio of the Mineral Rent(as % of GDP) of Coal in 2007 to that in 2010?
Provide a succinct answer. 0.41. What is the ratio of the Mineral Rent(as % of GDP) in Natural Gas in 2007 to that in 2010?
Ensure brevity in your answer.  2.06. What is the ratio of the Mineral Rent(as % of GDP) in Oil in 2007 to that in 2010?
Your answer should be very brief. 1.04. What is the ratio of the Mineral Rent(as % of GDP) of Other Minerals in 2007 to that in 2010?
Ensure brevity in your answer.  1.38. What is the ratio of the Mineral Rent(as % of GDP) in Coal in 2007 to that in 2011?
Make the answer very short. 0.29. What is the ratio of the Mineral Rent(as % of GDP) in Natural Gas in 2007 to that in 2011?
Your answer should be compact. 1.93. What is the ratio of the Mineral Rent(as % of GDP) in Oil in 2007 to that in 2011?
Provide a succinct answer. 0.95. What is the ratio of the Mineral Rent(as % of GDP) in Other Minerals in 2007 to that in 2011?
Keep it short and to the point. 1.25. What is the ratio of the Mineral Rent(as % of GDP) in Coal in 2007 to that in 2012?
Ensure brevity in your answer.  0.44. What is the ratio of the Mineral Rent(as % of GDP) of Natural Gas in 2007 to that in 2012?
Keep it short and to the point. 2.52. What is the ratio of the Mineral Rent(as % of GDP) in Oil in 2007 to that in 2012?
Your answer should be very brief. 1.26. What is the ratio of the Mineral Rent(as % of GDP) in Other Minerals in 2007 to that in 2012?
Keep it short and to the point. 1.3. What is the ratio of the Mineral Rent(as % of GDP) in Coal in 2008 to that in 2009?
Make the answer very short. 2.06. What is the ratio of the Mineral Rent(as % of GDP) in Natural Gas in 2008 to that in 2009?
Provide a short and direct response. 2.06. What is the ratio of the Mineral Rent(as % of GDP) of Oil in 2008 to that in 2009?
Keep it short and to the point. 1.3. What is the ratio of the Mineral Rent(as % of GDP) of Other Minerals in 2008 to that in 2009?
Your response must be concise. 0.81. What is the ratio of the Mineral Rent(as % of GDP) in Natural Gas in 2008 to that in 2010?
Your response must be concise. 2.72. What is the ratio of the Mineral Rent(as % of GDP) in Oil in 2008 to that in 2010?
Offer a terse response. 1.34. What is the ratio of the Mineral Rent(as % of GDP) in Other Minerals in 2008 to that in 2010?
Offer a very short reply. 0.45. What is the ratio of the Mineral Rent(as % of GDP) of Coal in 2008 to that in 2011?
Offer a very short reply. 0.72. What is the ratio of the Mineral Rent(as % of GDP) in Natural Gas in 2008 to that in 2011?
Provide a succinct answer. 2.55. What is the ratio of the Mineral Rent(as % of GDP) of Oil in 2008 to that in 2011?
Give a very brief answer. 1.23. What is the ratio of the Mineral Rent(as % of GDP) in Other Minerals in 2008 to that in 2011?
Offer a very short reply. 0.4. What is the ratio of the Mineral Rent(as % of GDP) in Coal in 2008 to that in 2012?
Provide a short and direct response. 1.1. What is the ratio of the Mineral Rent(as % of GDP) in Natural Gas in 2008 to that in 2012?
Keep it short and to the point. 3.33. What is the ratio of the Mineral Rent(as % of GDP) of Oil in 2008 to that in 2012?
Ensure brevity in your answer.  1.63. What is the ratio of the Mineral Rent(as % of GDP) in Other Minerals in 2008 to that in 2012?
Provide a succinct answer. 0.42. What is the ratio of the Mineral Rent(as % of GDP) in Coal in 2009 to that in 2010?
Offer a very short reply. 0.49. What is the ratio of the Mineral Rent(as % of GDP) in Natural Gas in 2009 to that in 2010?
Keep it short and to the point. 1.32. What is the ratio of the Mineral Rent(as % of GDP) of Oil in 2009 to that in 2010?
Offer a very short reply. 1.04. What is the ratio of the Mineral Rent(as % of GDP) in Other Minerals in 2009 to that in 2010?
Make the answer very short. 0.55. What is the ratio of the Mineral Rent(as % of GDP) in Coal in 2009 to that in 2011?
Your response must be concise. 0.35. What is the ratio of the Mineral Rent(as % of GDP) of Natural Gas in 2009 to that in 2011?
Offer a terse response. 1.24. What is the ratio of the Mineral Rent(as % of GDP) in Oil in 2009 to that in 2011?
Your response must be concise. 0.95. What is the ratio of the Mineral Rent(as % of GDP) in Other Minerals in 2009 to that in 2011?
Make the answer very short. 0.5. What is the ratio of the Mineral Rent(as % of GDP) in Coal in 2009 to that in 2012?
Your answer should be very brief. 0.53. What is the ratio of the Mineral Rent(as % of GDP) of Natural Gas in 2009 to that in 2012?
Offer a very short reply. 1.62. What is the ratio of the Mineral Rent(as % of GDP) of Oil in 2009 to that in 2012?
Offer a very short reply. 1.26. What is the ratio of the Mineral Rent(as % of GDP) of Other Minerals in 2009 to that in 2012?
Make the answer very short. 0.52. What is the ratio of the Mineral Rent(as % of GDP) in Coal in 2010 to that in 2011?
Provide a short and direct response. 0.72. What is the ratio of the Mineral Rent(as % of GDP) of Natural Gas in 2010 to that in 2011?
Offer a very short reply. 0.94. What is the ratio of the Mineral Rent(as % of GDP) of Oil in 2010 to that in 2011?
Ensure brevity in your answer.  0.91. What is the ratio of the Mineral Rent(as % of GDP) in Other Minerals in 2010 to that in 2011?
Ensure brevity in your answer.  0.9. What is the ratio of the Mineral Rent(as % of GDP) of Coal in 2010 to that in 2012?
Provide a short and direct response. 1.1. What is the ratio of the Mineral Rent(as % of GDP) of Natural Gas in 2010 to that in 2012?
Give a very brief answer. 1.22. What is the ratio of the Mineral Rent(as % of GDP) of Oil in 2010 to that in 2012?
Provide a succinct answer. 1.21. What is the ratio of the Mineral Rent(as % of GDP) in Other Minerals in 2010 to that in 2012?
Keep it short and to the point. 0.94. What is the ratio of the Mineral Rent(as % of GDP) in Coal in 2011 to that in 2012?
Ensure brevity in your answer.  1.53. What is the ratio of the Mineral Rent(as % of GDP) of Natural Gas in 2011 to that in 2012?
Give a very brief answer. 1.31. What is the ratio of the Mineral Rent(as % of GDP) of Oil in 2011 to that in 2012?
Your answer should be compact. 1.33. What is the ratio of the Mineral Rent(as % of GDP) of Other Minerals in 2011 to that in 2012?
Provide a succinct answer. 1.04. What is the difference between the highest and the second highest Mineral Rent(as % of GDP) in Coal?
Provide a short and direct response. 0.09. What is the difference between the highest and the second highest Mineral Rent(as % of GDP) in Natural Gas?
Provide a short and direct response. 0.18. What is the difference between the highest and the second highest Mineral Rent(as % of GDP) of Oil?
Make the answer very short. 0.06. What is the difference between the highest and the second highest Mineral Rent(as % of GDP) of Other Minerals?
Give a very brief answer. 0.74. What is the difference between the highest and the lowest Mineral Rent(as % of GDP) of Coal?
Your response must be concise. 0.22. What is the difference between the highest and the lowest Mineral Rent(as % of GDP) of Natural Gas?
Provide a succinct answer. 0.53. What is the difference between the highest and the lowest Mineral Rent(as % of GDP) of Oil?
Offer a very short reply. 0.13. What is the difference between the highest and the lowest Mineral Rent(as % of GDP) in Other Minerals?
Your answer should be compact. 2.49. 